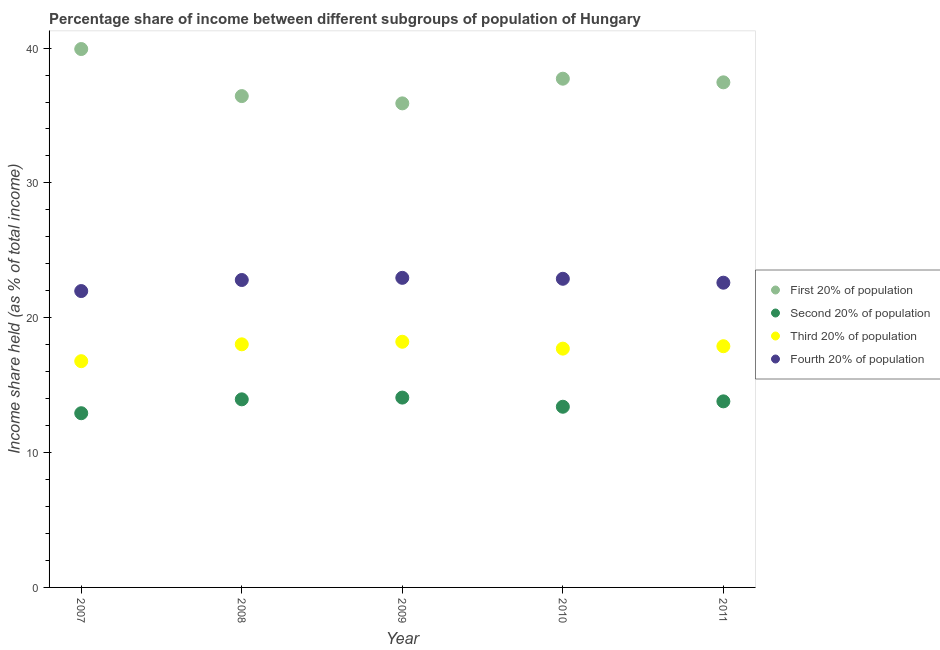Is the number of dotlines equal to the number of legend labels?
Your response must be concise. Yes. What is the share of the income held by third 20% of the population in 2010?
Ensure brevity in your answer.  17.71. Across all years, what is the maximum share of the income held by first 20% of the population?
Ensure brevity in your answer.  39.93. Across all years, what is the minimum share of the income held by third 20% of the population?
Your answer should be very brief. 16.78. What is the total share of the income held by second 20% of the population in the graph?
Make the answer very short. 68.15. What is the difference between the share of the income held by first 20% of the population in 2008 and that in 2009?
Your answer should be compact. 0.54. What is the difference between the share of the income held by first 20% of the population in 2010 and the share of the income held by second 20% of the population in 2009?
Provide a short and direct response. 23.65. What is the average share of the income held by fourth 20% of the population per year?
Your answer should be very brief. 22.65. In the year 2007, what is the difference between the share of the income held by fourth 20% of the population and share of the income held by third 20% of the population?
Make the answer very short. 5.2. What is the ratio of the share of the income held by second 20% of the population in 2007 to that in 2010?
Keep it short and to the point. 0.96. Is the share of the income held by first 20% of the population in 2007 less than that in 2010?
Your response must be concise. No. What is the difference between the highest and the second highest share of the income held by second 20% of the population?
Your answer should be very brief. 0.13. What is the difference between the highest and the lowest share of the income held by third 20% of the population?
Offer a terse response. 1.44. Is the sum of the share of the income held by second 20% of the population in 2009 and 2011 greater than the maximum share of the income held by fourth 20% of the population across all years?
Provide a succinct answer. Yes. Is it the case that in every year, the sum of the share of the income held by second 20% of the population and share of the income held by fourth 20% of the population is greater than the sum of share of the income held by first 20% of the population and share of the income held by third 20% of the population?
Offer a very short reply. No. Does the share of the income held by second 20% of the population monotonically increase over the years?
Keep it short and to the point. No. Is the share of the income held by first 20% of the population strictly greater than the share of the income held by third 20% of the population over the years?
Your answer should be very brief. Yes. Is the share of the income held by third 20% of the population strictly less than the share of the income held by fourth 20% of the population over the years?
Your answer should be compact. Yes. How many dotlines are there?
Ensure brevity in your answer.  4. What is the difference between two consecutive major ticks on the Y-axis?
Provide a succinct answer. 10. Does the graph contain any zero values?
Provide a short and direct response. No. Does the graph contain grids?
Make the answer very short. No. Where does the legend appear in the graph?
Provide a short and direct response. Center right. How many legend labels are there?
Your answer should be compact. 4. What is the title of the graph?
Provide a succinct answer. Percentage share of income between different subgroups of population of Hungary. Does "SF6 gas" appear as one of the legend labels in the graph?
Your answer should be very brief. No. What is the label or title of the Y-axis?
Provide a succinct answer. Income share held (as % of total income). What is the Income share held (as % of total income) of First 20% of population in 2007?
Offer a very short reply. 39.93. What is the Income share held (as % of total income) of Second 20% of population in 2007?
Provide a succinct answer. 12.92. What is the Income share held (as % of total income) of Third 20% of population in 2007?
Provide a succinct answer. 16.78. What is the Income share held (as % of total income) in Fourth 20% of population in 2007?
Ensure brevity in your answer.  21.98. What is the Income share held (as % of total income) of First 20% of population in 2008?
Offer a very short reply. 36.44. What is the Income share held (as % of total income) of Second 20% of population in 2008?
Offer a terse response. 13.95. What is the Income share held (as % of total income) in Third 20% of population in 2008?
Give a very brief answer. 18.03. What is the Income share held (as % of total income) of Fourth 20% of population in 2008?
Make the answer very short. 22.8. What is the Income share held (as % of total income) in First 20% of population in 2009?
Keep it short and to the point. 35.9. What is the Income share held (as % of total income) of Second 20% of population in 2009?
Your answer should be compact. 14.08. What is the Income share held (as % of total income) of Third 20% of population in 2009?
Provide a succinct answer. 18.22. What is the Income share held (as % of total income) of Fourth 20% of population in 2009?
Ensure brevity in your answer.  22.96. What is the Income share held (as % of total income) of First 20% of population in 2010?
Keep it short and to the point. 37.73. What is the Income share held (as % of total income) of Second 20% of population in 2010?
Provide a succinct answer. 13.4. What is the Income share held (as % of total income) in Third 20% of population in 2010?
Offer a terse response. 17.71. What is the Income share held (as % of total income) in Fourth 20% of population in 2010?
Offer a terse response. 22.89. What is the Income share held (as % of total income) in First 20% of population in 2011?
Offer a terse response. 37.46. What is the Income share held (as % of total income) of Second 20% of population in 2011?
Your answer should be very brief. 13.8. What is the Income share held (as % of total income) in Third 20% of population in 2011?
Your answer should be compact. 17.89. What is the Income share held (as % of total income) in Fourth 20% of population in 2011?
Ensure brevity in your answer.  22.6. Across all years, what is the maximum Income share held (as % of total income) in First 20% of population?
Offer a very short reply. 39.93. Across all years, what is the maximum Income share held (as % of total income) in Second 20% of population?
Provide a short and direct response. 14.08. Across all years, what is the maximum Income share held (as % of total income) of Third 20% of population?
Make the answer very short. 18.22. Across all years, what is the maximum Income share held (as % of total income) of Fourth 20% of population?
Your response must be concise. 22.96. Across all years, what is the minimum Income share held (as % of total income) in First 20% of population?
Make the answer very short. 35.9. Across all years, what is the minimum Income share held (as % of total income) of Second 20% of population?
Your response must be concise. 12.92. Across all years, what is the minimum Income share held (as % of total income) of Third 20% of population?
Your response must be concise. 16.78. Across all years, what is the minimum Income share held (as % of total income) in Fourth 20% of population?
Make the answer very short. 21.98. What is the total Income share held (as % of total income) in First 20% of population in the graph?
Your response must be concise. 187.46. What is the total Income share held (as % of total income) in Second 20% of population in the graph?
Your answer should be very brief. 68.15. What is the total Income share held (as % of total income) in Third 20% of population in the graph?
Your response must be concise. 88.63. What is the total Income share held (as % of total income) in Fourth 20% of population in the graph?
Your answer should be compact. 113.23. What is the difference between the Income share held (as % of total income) in First 20% of population in 2007 and that in 2008?
Offer a terse response. 3.49. What is the difference between the Income share held (as % of total income) in Second 20% of population in 2007 and that in 2008?
Your response must be concise. -1.03. What is the difference between the Income share held (as % of total income) in Third 20% of population in 2007 and that in 2008?
Your answer should be very brief. -1.25. What is the difference between the Income share held (as % of total income) in Fourth 20% of population in 2007 and that in 2008?
Your response must be concise. -0.82. What is the difference between the Income share held (as % of total income) of First 20% of population in 2007 and that in 2009?
Offer a terse response. 4.03. What is the difference between the Income share held (as % of total income) in Second 20% of population in 2007 and that in 2009?
Make the answer very short. -1.16. What is the difference between the Income share held (as % of total income) of Third 20% of population in 2007 and that in 2009?
Provide a short and direct response. -1.44. What is the difference between the Income share held (as % of total income) of Fourth 20% of population in 2007 and that in 2009?
Your answer should be very brief. -0.98. What is the difference between the Income share held (as % of total income) in First 20% of population in 2007 and that in 2010?
Give a very brief answer. 2.2. What is the difference between the Income share held (as % of total income) in Second 20% of population in 2007 and that in 2010?
Provide a succinct answer. -0.48. What is the difference between the Income share held (as % of total income) in Third 20% of population in 2007 and that in 2010?
Offer a very short reply. -0.93. What is the difference between the Income share held (as % of total income) in Fourth 20% of population in 2007 and that in 2010?
Ensure brevity in your answer.  -0.91. What is the difference between the Income share held (as % of total income) of First 20% of population in 2007 and that in 2011?
Your answer should be very brief. 2.47. What is the difference between the Income share held (as % of total income) of Second 20% of population in 2007 and that in 2011?
Offer a very short reply. -0.88. What is the difference between the Income share held (as % of total income) of Third 20% of population in 2007 and that in 2011?
Provide a short and direct response. -1.11. What is the difference between the Income share held (as % of total income) in Fourth 20% of population in 2007 and that in 2011?
Provide a short and direct response. -0.62. What is the difference between the Income share held (as % of total income) of First 20% of population in 2008 and that in 2009?
Provide a succinct answer. 0.54. What is the difference between the Income share held (as % of total income) in Second 20% of population in 2008 and that in 2009?
Provide a short and direct response. -0.13. What is the difference between the Income share held (as % of total income) of Third 20% of population in 2008 and that in 2009?
Keep it short and to the point. -0.19. What is the difference between the Income share held (as % of total income) of Fourth 20% of population in 2008 and that in 2009?
Offer a terse response. -0.16. What is the difference between the Income share held (as % of total income) of First 20% of population in 2008 and that in 2010?
Ensure brevity in your answer.  -1.29. What is the difference between the Income share held (as % of total income) in Second 20% of population in 2008 and that in 2010?
Provide a short and direct response. 0.55. What is the difference between the Income share held (as % of total income) of Third 20% of population in 2008 and that in 2010?
Provide a short and direct response. 0.32. What is the difference between the Income share held (as % of total income) in Fourth 20% of population in 2008 and that in 2010?
Offer a very short reply. -0.09. What is the difference between the Income share held (as % of total income) in First 20% of population in 2008 and that in 2011?
Your response must be concise. -1.02. What is the difference between the Income share held (as % of total income) of Second 20% of population in 2008 and that in 2011?
Your answer should be compact. 0.15. What is the difference between the Income share held (as % of total income) of Third 20% of population in 2008 and that in 2011?
Ensure brevity in your answer.  0.14. What is the difference between the Income share held (as % of total income) in Fourth 20% of population in 2008 and that in 2011?
Make the answer very short. 0.2. What is the difference between the Income share held (as % of total income) in First 20% of population in 2009 and that in 2010?
Your answer should be very brief. -1.83. What is the difference between the Income share held (as % of total income) of Second 20% of population in 2009 and that in 2010?
Provide a succinct answer. 0.68. What is the difference between the Income share held (as % of total income) in Third 20% of population in 2009 and that in 2010?
Your answer should be compact. 0.51. What is the difference between the Income share held (as % of total income) in Fourth 20% of population in 2009 and that in 2010?
Ensure brevity in your answer.  0.07. What is the difference between the Income share held (as % of total income) in First 20% of population in 2009 and that in 2011?
Offer a very short reply. -1.56. What is the difference between the Income share held (as % of total income) of Second 20% of population in 2009 and that in 2011?
Give a very brief answer. 0.28. What is the difference between the Income share held (as % of total income) of Third 20% of population in 2009 and that in 2011?
Your answer should be very brief. 0.33. What is the difference between the Income share held (as % of total income) of Fourth 20% of population in 2009 and that in 2011?
Provide a short and direct response. 0.36. What is the difference between the Income share held (as % of total income) in First 20% of population in 2010 and that in 2011?
Keep it short and to the point. 0.27. What is the difference between the Income share held (as % of total income) in Second 20% of population in 2010 and that in 2011?
Offer a very short reply. -0.4. What is the difference between the Income share held (as % of total income) of Third 20% of population in 2010 and that in 2011?
Keep it short and to the point. -0.18. What is the difference between the Income share held (as % of total income) of Fourth 20% of population in 2010 and that in 2011?
Offer a terse response. 0.29. What is the difference between the Income share held (as % of total income) in First 20% of population in 2007 and the Income share held (as % of total income) in Second 20% of population in 2008?
Provide a succinct answer. 25.98. What is the difference between the Income share held (as % of total income) in First 20% of population in 2007 and the Income share held (as % of total income) in Third 20% of population in 2008?
Your answer should be very brief. 21.9. What is the difference between the Income share held (as % of total income) of First 20% of population in 2007 and the Income share held (as % of total income) of Fourth 20% of population in 2008?
Your answer should be very brief. 17.13. What is the difference between the Income share held (as % of total income) of Second 20% of population in 2007 and the Income share held (as % of total income) of Third 20% of population in 2008?
Offer a very short reply. -5.11. What is the difference between the Income share held (as % of total income) in Second 20% of population in 2007 and the Income share held (as % of total income) in Fourth 20% of population in 2008?
Provide a succinct answer. -9.88. What is the difference between the Income share held (as % of total income) in Third 20% of population in 2007 and the Income share held (as % of total income) in Fourth 20% of population in 2008?
Give a very brief answer. -6.02. What is the difference between the Income share held (as % of total income) of First 20% of population in 2007 and the Income share held (as % of total income) of Second 20% of population in 2009?
Ensure brevity in your answer.  25.85. What is the difference between the Income share held (as % of total income) of First 20% of population in 2007 and the Income share held (as % of total income) of Third 20% of population in 2009?
Give a very brief answer. 21.71. What is the difference between the Income share held (as % of total income) in First 20% of population in 2007 and the Income share held (as % of total income) in Fourth 20% of population in 2009?
Ensure brevity in your answer.  16.97. What is the difference between the Income share held (as % of total income) of Second 20% of population in 2007 and the Income share held (as % of total income) of Third 20% of population in 2009?
Provide a succinct answer. -5.3. What is the difference between the Income share held (as % of total income) of Second 20% of population in 2007 and the Income share held (as % of total income) of Fourth 20% of population in 2009?
Your response must be concise. -10.04. What is the difference between the Income share held (as % of total income) of Third 20% of population in 2007 and the Income share held (as % of total income) of Fourth 20% of population in 2009?
Offer a terse response. -6.18. What is the difference between the Income share held (as % of total income) in First 20% of population in 2007 and the Income share held (as % of total income) in Second 20% of population in 2010?
Provide a succinct answer. 26.53. What is the difference between the Income share held (as % of total income) in First 20% of population in 2007 and the Income share held (as % of total income) in Third 20% of population in 2010?
Ensure brevity in your answer.  22.22. What is the difference between the Income share held (as % of total income) of First 20% of population in 2007 and the Income share held (as % of total income) of Fourth 20% of population in 2010?
Keep it short and to the point. 17.04. What is the difference between the Income share held (as % of total income) of Second 20% of population in 2007 and the Income share held (as % of total income) of Third 20% of population in 2010?
Give a very brief answer. -4.79. What is the difference between the Income share held (as % of total income) of Second 20% of population in 2007 and the Income share held (as % of total income) of Fourth 20% of population in 2010?
Give a very brief answer. -9.97. What is the difference between the Income share held (as % of total income) in Third 20% of population in 2007 and the Income share held (as % of total income) in Fourth 20% of population in 2010?
Keep it short and to the point. -6.11. What is the difference between the Income share held (as % of total income) in First 20% of population in 2007 and the Income share held (as % of total income) in Second 20% of population in 2011?
Offer a very short reply. 26.13. What is the difference between the Income share held (as % of total income) in First 20% of population in 2007 and the Income share held (as % of total income) in Third 20% of population in 2011?
Your response must be concise. 22.04. What is the difference between the Income share held (as % of total income) in First 20% of population in 2007 and the Income share held (as % of total income) in Fourth 20% of population in 2011?
Your response must be concise. 17.33. What is the difference between the Income share held (as % of total income) in Second 20% of population in 2007 and the Income share held (as % of total income) in Third 20% of population in 2011?
Give a very brief answer. -4.97. What is the difference between the Income share held (as % of total income) of Second 20% of population in 2007 and the Income share held (as % of total income) of Fourth 20% of population in 2011?
Ensure brevity in your answer.  -9.68. What is the difference between the Income share held (as % of total income) of Third 20% of population in 2007 and the Income share held (as % of total income) of Fourth 20% of population in 2011?
Ensure brevity in your answer.  -5.82. What is the difference between the Income share held (as % of total income) in First 20% of population in 2008 and the Income share held (as % of total income) in Second 20% of population in 2009?
Your answer should be very brief. 22.36. What is the difference between the Income share held (as % of total income) of First 20% of population in 2008 and the Income share held (as % of total income) of Third 20% of population in 2009?
Ensure brevity in your answer.  18.22. What is the difference between the Income share held (as % of total income) in First 20% of population in 2008 and the Income share held (as % of total income) in Fourth 20% of population in 2009?
Your response must be concise. 13.48. What is the difference between the Income share held (as % of total income) of Second 20% of population in 2008 and the Income share held (as % of total income) of Third 20% of population in 2009?
Provide a succinct answer. -4.27. What is the difference between the Income share held (as % of total income) in Second 20% of population in 2008 and the Income share held (as % of total income) in Fourth 20% of population in 2009?
Your answer should be compact. -9.01. What is the difference between the Income share held (as % of total income) in Third 20% of population in 2008 and the Income share held (as % of total income) in Fourth 20% of population in 2009?
Ensure brevity in your answer.  -4.93. What is the difference between the Income share held (as % of total income) of First 20% of population in 2008 and the Income share held (as % of total income) of Second 20% of population in 2010?
Your answer should be compact. 23.04. What is the difference between the Income share held (as % of total income) in First 20% of population in 2008 and the Income share held (as % of total income) in Third 20% of population in 2010?
Your answer should be compact. 18.73. What is the difference between the Income share held (as % of total income) of First 20% of population in 2008 and the Income share held (as % of total income) of Fourth 20% of population in 2010?
Your answer should be very brief. 13.55. What is the difference between the Income share held (as % of total income) in Second 20% of population in 2008 and the Income share held (as % of total income) in Third 20% of population in 2010?
Your response must be concise. -3.76. What is the difference between the Income share held (as % of total income) in Second 20% of population in 2008 and the Income share held (as % of total income) in Fourth 20% of population in 2010?
Your answer should be very brief. -8.94. What is the difference between the Income share held (as % of total income) of Third 20% of population in 2008 and the Income share held (as % of total income) of Fourth 20% of population in 2010?
Provide a short and direct response. -4.86. What is the difference between the Income share held (as % of total income) of First 20% of population in 2008 and the Income share held (as % of total income) of Second 20% of population in 2011?
Keep it short and to the point. 22.64. What is the difference between the Income share held (as % of total income) in First 20% of population in 2008 and the Income share held (as % of total income) in Third 20% of population in 2011?
Your response must be concise. 18.55. What is the difference between the Income share held (as % of total income) in First 20% of population in 2008 and the Income share held (as % of total income) in Fourth 20% of population in 2011?
Your answer should be very brief. 13.84. What is the difference between the Income share held (as % of total income) of Second 20% of population in 2008 and the Income share held (as % of total income) of Third 20% of population in 2011?
Ensure brevity in your answer.  -3.94. What is the difference between the Income share held (as % of total income) in Second 20% of population in 2008 and the Income share held (as % of total income) in Fourth 20% of population in 2011?
Make the answer very short. -8.65. What is the difference between the Income share held (as % of total income) in Third 20% of population in 2008 and the Income share held (as % of total income) in Fourth 20% of population in 2011?
Offer a terse response. -4.57. What is the difference between the Income share held (as % of total income) of First 20% of population in 2009 and the Income share held (as % of total income) of Second 20% of population in 2010?
Offer a terse response. 22.5. What is the difference between the Income share held (as % of total income) of First 20% of population in 2009 and the Income share held (as % of total income) of Third 20% of population in 2010?
Make the answer very short. 18.19. What is the difference between the Income share held (as % of total income) of First 20% of population in 2009 and the Income share held (as % of total income) of Fourth 20% of population in 2010?
Provide a short and direct response. 13.01. What is the difference between the Income share held (as % of total income) in Second 20% of population in 2009 and the Income share held (as % of total income) in Third 20% of population in 2010?
Offer a very short reply. -3.63. What is the difference between the Income share held (as % of total income) in Second 20% of population in 2009 and the Income share held (as % of total income) in Fourth 20% of population in 2010?
Offer a very short reply. -8.81. What is the difference between the Income share held (as % of total income) in Third 20% of population in 2009 and the Income share held (as % of total income) in Fourth 20% of population in 2010?
Your answer should be compact. -4.67. What is the difference between the Income share held (as % of total income) of First 20% of population in 2009 and the Income share held (as % of total income) of Second 20% of population in 2011?
Your answer should be compact. 22.1. What is the difference between the Income share held (as % of total income) of First 20% of population in 2009 and the Income share held (as % of total income) of Third 20% of population in 2011?
Give a very brief answer. 18.01. What is the difference between the Income share held (as % of total income) of First 20% of population in 2009 and the Income share held (as % of total income) of Fourth 20% of population in 2011?
Offer a very short reply. 13.3. What is the difference between the Income share held (as % of total income) in Second 20% of population in 2009 and the Income share held (as % of total income) in Third 20% of population in 2011?
Keep it short and to the point. -3.81. What is the difference between the Income share held (as % of total income) in Second 20% of population in 2009 and the Income share held (as % of total income) in Fourth 20% of population in 2011?
Provide a succinct answer. -8.52. What is the difference between the Income share held (as % of total income) in Third 20% of population in 2009 and the Income share held (as % of total income) in Fourth 20% of population in 2011?
Give a very brief answer. -4.38. What is the difference between the Income share held (as % of total income) in First 20% of population in 2010 and the Income share held (as % of total income) in Second 20% of population in 2011?
Provide a short and direct response. 23.93. What is the difference between the Income share held (as % of total income) of First 20% of population in 2010 and the Income share held (as % of total income) of Third 20% of population in 2011?
Your response must be concise. 19.84. What is the difference between the Income share held (as % of total income) in First 20% of population in 2010 and the Income share held (as % of total income) in Fourth 20% of population in 2011?
Keep it short and to the point. 15.13. What is the difference between the Income share held (as % of total income) of Second 20% of population in 2010 and the Income share held (as % of total income) of Third 20% of population in 2011?
Provide a succinct answer. -4.49. What is the difference between the Income share held (as % of total income) of Second 20% of population in 2010 and the Income share held (as % of total income) of Fourth 20% of population in 2011?
Offer a very short reply. -9.2. What is the difference between the Income share held (as % of total income) in Third 20% of population in 2010 and the Income share held (as % of total income) in Fourth 20% of population in 2011?
Your response must be concise. -4.89. What is the average Income share held (as % of total income) of First 20% of population per year?
Offer a very short reply. 37.49. What is the average Income share held (as % of total income) in Second 20% of population per year?
Offer a very short reply. 13.63. What is the average Income share held (as % of total income) in Third 20% of population per year?
Offer a very short reply. 17.73. What is the average Income share held (as % of total income) of Fourth 20% of population per year?
Give a very brief answer. 22.65. In the year 2007, what is the difference between the Income share held (as % of total income) in First 20% of population and Income share held (as % of total income) in Second 20% of population?
Keep it short and to the point. 27.01. In the year 2007, what is the difference between the Income share held (as % of total income) of First 20% of population and Income share held (as % of total income) of Third 20% of population?
Your answer should be compact. 23.15. In the year 2007, what is the difference between the Income share held (as % of total income) of First 20% of population and Income share held (as % of total income) of Fourth 20% of population?
Ensure brevity in your answer.  17.95. In the year 2007, what is the difference between the Income share held (as % of total income) of Second 20% of population and Income share held (as % of total income) of Third 20% of population?
Ensure brevity in your answer.  -3.86. In the year 2007, what is the difference between the Income share held (as % of total income) in Second 20% of population and Income share held (as % of total income) in Fourth 20% of population?
Offer a terse response. -9.06. In the year 2008, what is the difference between the Income share held (as % of total income) of First 20% of population and Income share held (as % of total income) of Second 20% of population?
Your answer should be very brief. 22.49. In the year 2008, what is the difference between the Income share held (as % of total income) in First 20% of population and Income share held (as % of total income) in Third 20% of population?
Your answer should be compact. 18.41. In the year 2008, what is the difference between the Income share held (as % of total income) of First 20% of population and Income share held (as % of total income) of Fourth 20% of population?
Provide a short and direct response. 13.64. In the year 2008, what is the difference between the Income share held (as % of total income) in Second 20% of population and Income share held (as % of total income) in Third 20% of population?
Offer a terse response. -4.08. In the year 2008, what is the difference between the Income share held (as % of total income) of Second 20% of population and Income share held (as % of total income) of Fourth 20% of population?
Your answer should be compact. -8.85. In the year 2008, what is the difference between the Income share held (as % of total income) in Third 20% of population and Income share held (as % of total income) in Fourth 20% of population?
Your answer should be compact. -4.77. In the year 2009, what is the difference between the Income share held (as % of total income) in First 20% of population and Income share held (as % of total income) in Second 20% of population?
Offer a very short reply. 21.82. In the year 2009, what is the difference between the Income share held (as % of total income) of First 20% of population and Income share held (as % of total income) of Third 20% of population?
Offer a terse response. 17.68. In the year 2009, what is the difference between the Income share held (as % of total income) of First 20% of population and Income share held (as % of total income) of Fourth 20% of population?
Your response must be concise. 12.94. In the year 2009, what is the difference between the Income share held (as % of total income) of Second 20% of population and Income share held (as % of total income) of Third 20% of population?
Provide a succinct answer. -4.14. In the year 2009, what is the difference between the Income share held (as % of total income) of Second 20% of population and Income share held (as % of total income) of Fourth 20% of population?
Your answer should be compact. -8.88. In the year 2009, what is the difference between the Income share held (as % of total income) in Third 20% of population and Income share held (as % of total income) in Fourth 20% of population?
Provide a short and direct response. -4.74. In the year 2010, what is the difference between the Income share held (as % of total income) in First 20% of population and Income share held (as % of total income) in Second 20% of population?
Give a very brief answer. 24.33. In the year 2010, what is the difference between the Income share held (as % of total income) of First 20% of population and Income share held (as % of total income) of Third 20% of population?
Ensure brevity in your answer.  20.02. In the year 2010, what is the difference between the Income share held (as % of total income) in First 20% of population and Income share held (as % of total income) in Fourth 20% of population?
Give a very brief answer. 14.84. In the year 2010, what is the difference between the Income share held (as % of total income) in Second 20% of population and Income share held (as % of total income) in Third 20% of population?
Offer a terse response. -4.31. In the year 2010, what is the difference between the Income share held (as % of total income) of Second 20% of population and Income share held (as % of total income) of Fourth 20% of population?
Make the answer very short. -9.49. In the year 2010, what is the difference between the Income share held (as % of total income) of Third 20% of population and Income share held (as % of total income) of Fourth 20% of population?
Offer a terse response. -5.18. In the year 2011, what is the difference between the Income share held (as % of total income) of First 20% of population and Income share held (as % of total income) of Second 20% of population?
Offer a very short reply. 23.66. In the year 2011, what is the difference between the Income share held (as % of total income) of First 20% of population and Income share held (as % of total income) of Third 20% of population?
Make the answer very short. 19.57. In the year 2011, what is the difference between the Income share held (as % of total income) in First 20% of population and Income share held (as % of total income) in Fourth 20% of population?
Offer a terse response. 14.86. In the year 2011, what is the difference between the Income share held (as % of total income) of Second 20% of population and Income share held (as % of total income) of Third 20% of population?
Give a very brief answer. -4.09. In the year 2011, what is the difference between the Income share held (as % of total income) in Second 20% of population and Income share held (as % of total income) in Fourth 20% of population?
Your answer should be compact. -8.8. In the year 2011, what is the difference between the Income share held (as % of total income) in Third 20% of population and Income share held (as % of total income) in Fourth 20% of population?
Give a very brief answer. -4.71. What is the ratio of the Income share held (as % of total income) in First 20% of population in 2007 to that in 2008?
Make the answer very short. 1.1. What is the ratio of the Income share held (as % of total income) in Second 20% of population in 2007 to that in 2008?
Make the answer very short. 0.93. What is the ratio of the Income share held (as % of total income) in Third 20% of population in 2007 to that in 2008?
Provide a succinct answer. 0.93. What is the ratio of the Income share held (as % of total income) in First 20% of population in 2007 to that in 2009?
Provide a short and direct response. 1.11. What is the ratio of the Income share held (as % of total income) of Second 20% of population in 2007 to that in 2009?
Ensure brevity in your answer.  0.92. What is the ratio of the Income share held (as % of total income) in Third 20% of population in 2007 to that in 2009?
Your answer should be very brief. 0.92. What is the ratio of the Income share held (as % of total income) of Fourth 20% of population in 2007 to that in 2009?
Offer a very short reply. 0.96. What is the ratio of the Income share held (as % of total income) of First 20% of population in 2007 to that in 2010?
Provide a succinct answer. 1.06. What is the ratio of the Income share held (as % of total income) in Second 20% of population in 2007 to that in 2010?
Your response must be concise. 0.96. What is the ratio of the Income share held (as % of total income) of Third 20% of population in 2007 to that in 2010?
Ensure brevity in your answer.  0.95. What is the ratio of the Income share held (as % of total income) in Fourth 20% of population in 2007 to that in 2010?
Provide a succinct answer. 0.96. What is the ratio of the Income share held (as % of total income) of First 20% of population in 2007 to that in 2011?
Offer a very short reply. 1.07. What is the ratio of the Income share held (as % of total income) of Second 20% of population in 2007 to that in 2011?
Provide a succinct answer. 0.94. What is the ratio of the Income share held (as % of total income) in Third 20% of population in 2007 to that in 2011?
Your answer should be compact. 0.94. What is the ratio of the Income share held (as % of total income) in Fourth 20% of population in 2007 to that in 2011?
Offer a very short reply. 0.97. What is the ratio of the Income share held (as % of total income) in First 20% of population in 2008 to that in 2009?
Provide a short and direct response. 1.01. What is the ratio of the Income share held (as % of total income) of Second 20% of population in 2008 to that in 2009?
Provide a succinct answer. 0.99. What is the ratio of the Income share held (as % of total income) in Third 20% of population in 2008 to that in 2009?
Offer a terse response. 0.99. What is the ratio of the Income share held (as % of total income) of First 20% of population in 2008 to that in 2010?
Your answer should be compact. 0.97. What is the ratio of the Income share held (as % of total income) of Second 20% of population in 2008 to that in 2010?
Offer a very short reply. 1.04. What is the ratio of the Income share held (as % of total income) of Third 20% of population in 2008 to that in 2010?
Your answer should be compact. 1.02. What is the ratio of the Income share held (as % of total income) of First 20% of population in 2008 to that in 2011?
Give a very brief answer. 0.97. What is the ratio of the Income share held (as % of total income) of Second 20% of population in 2008 to that in 2011?
Provide a succinct answer. 1.01. What is the ratio of the Income share held (as % of total income) of Fourth 20% of population in 2008 to that in 2011?
Make the answer very short. 1.01. What is the ratio of the Income share held (as % of total income) in First 20% of population in 2009 to that in 2010?
Offer a terse response. 0.95. What is the ratio of the Income share held (as % of total income) of Second 20% of population in 2009 to that in 2010?
Make the answer very short. 1.05. What is the ratio of the Income share held (as % of total income) of Third 20% of population in 2009 to that in 2010?
Keep it short and to the point. 1.03. What is the ratio of the Income share held (as % of total income) in First 20% of population in 2009 to that in 2011?
Give a very brief answer. 0.96. What is the ratio of the Income share held (as % of total income) of Second 20% of population in 2009 to that in 2011?
Offer a very short reply. 1.02. What is the ratio of the Income share held (as % of total income) of Third 20% of population in 2009 to that in 2011?
Ensure brevity in your answer.  1.02. What is the ratio of the Income share held (as % of total income) in Fourth 20% of population in 2009 to that in 2011?
Give a very brief answer. 1.02. What is the ratio of the Income share held (as % of total income) of Fourth 20% of population in 2010 to that in 2011?
Ensure brevity in your answer.  1.01. What is the difference between the highest and the second highest Income share held (as % of total income) in Second 20% of population?
Provide a short and direct response. 0.13. What is the difference between the highest and the second highest Income share held (as % of total income) of Third 20% of population?
Offer a very short reply. 0.19. What is the difference between the highest and the second highest Income share held (as % of total income) in Fourth 20% of population?
Your response must be concise. 0.07. What is the difference between the highest and the lowest Income share held (as % of total income) in First 20% of population?
Offer a terse response. 4.03. What is the difference between the highest and the lowest Income share held (as % of total income) of Second 20% of population?
Your answer should be compact. 1.16. What is the difference between the highest and the lowest Income share held (as % of total income) in Third 20% of population?
Provide a succinct answer. 1.44. What is the difference between the highest and the lowest Income share held (as % of total income) in Fourth 20% of population?
Provide a succinct answer. 0.98. 